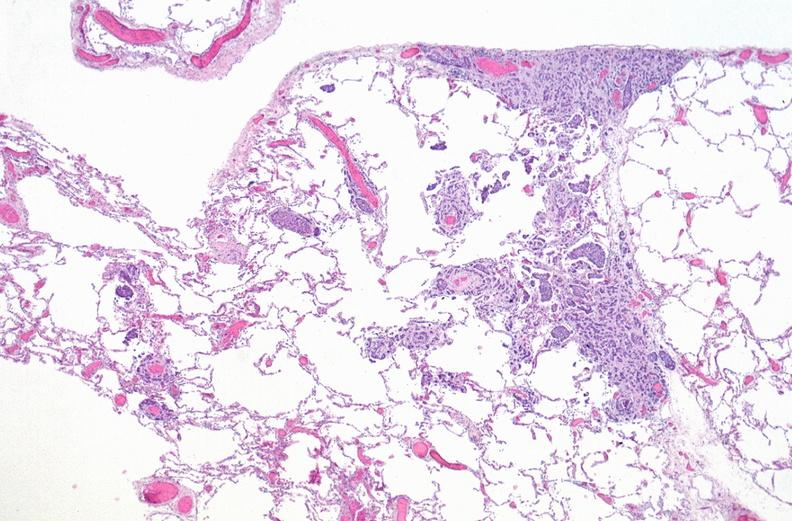what is present?
Answer the question using a single word or phrase. Respiratory 